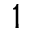<formula> <loc_0><loc_0><loc_500><loc_500>1</formula> 